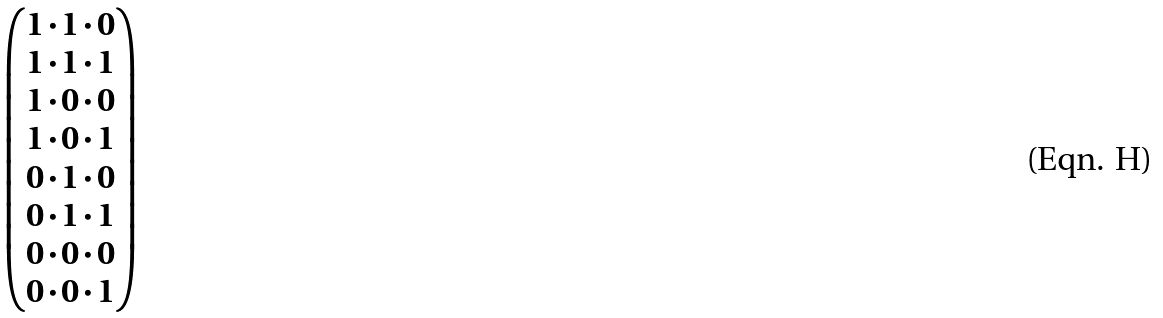<formula> <loc_0><loc_0><loc_500><loc_500>\begin{pmatrix} 1 \cdot 1 \cdot 0 \\ 1 \cdot 1 \cdot 1 \\ 1 \cdot 0 \cdot 0 \\ 1 \cdot 0 \cdot 1 \\ 0 \cdot 1 \cdot 0 \\ 0 \cdot 1 \cdot 1 \\ 0 \cdot 0 \cdot 0 \\ 0 \cdot 0 \cdot 1 \end{pmatrix}</formula> 